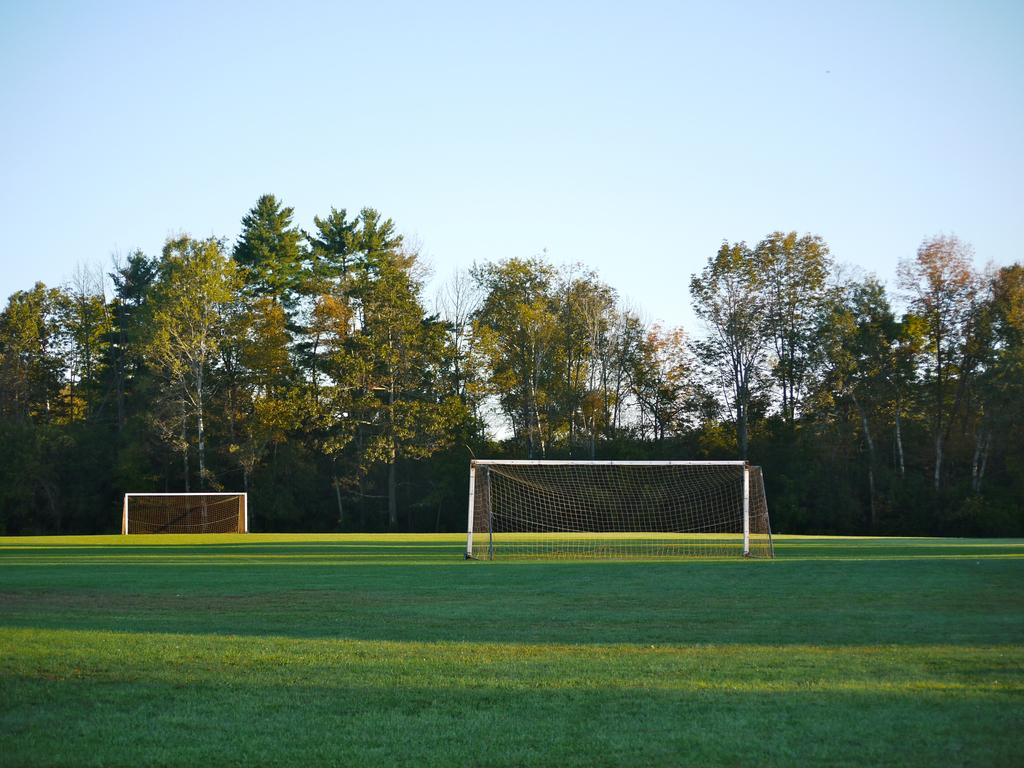What type of vegetation can be seen in the image? There are green color trees in the image. What structures are present in the image? There are goal posts in the image. What is the color of the grass in the image? There is green grass in the image. How would you describe the sky in the image? The sky is blue and white in color. How many letters are visible on the goal posts in the image? There are no letters visible on the goal posts in the image. What is the distance between the trees and the goal posts in the image? The provided facts do not give information about the distance between the trees and the goal posts, so it cannot be determined from the image. 